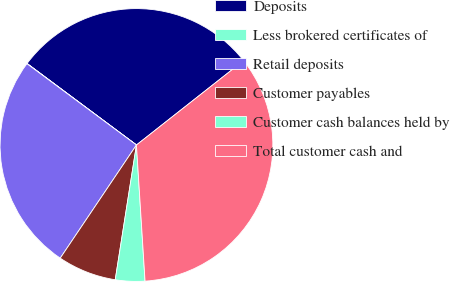<chart> <loc_0><loc_0><loc_500><loc_500><pie_chart><fcel>Deposits<fcel>Less brokered certificates of<fcel>Retail deposits<fcel>Customer payables<fcel>Customer cash balances held by<fcel>Total customer cash and<nl><fcel>29.19%<fcel>0.03%<fcel>25.73%<fcel>6.95%<fcel>3.49%<fcel>34.61%<nl></chart> 